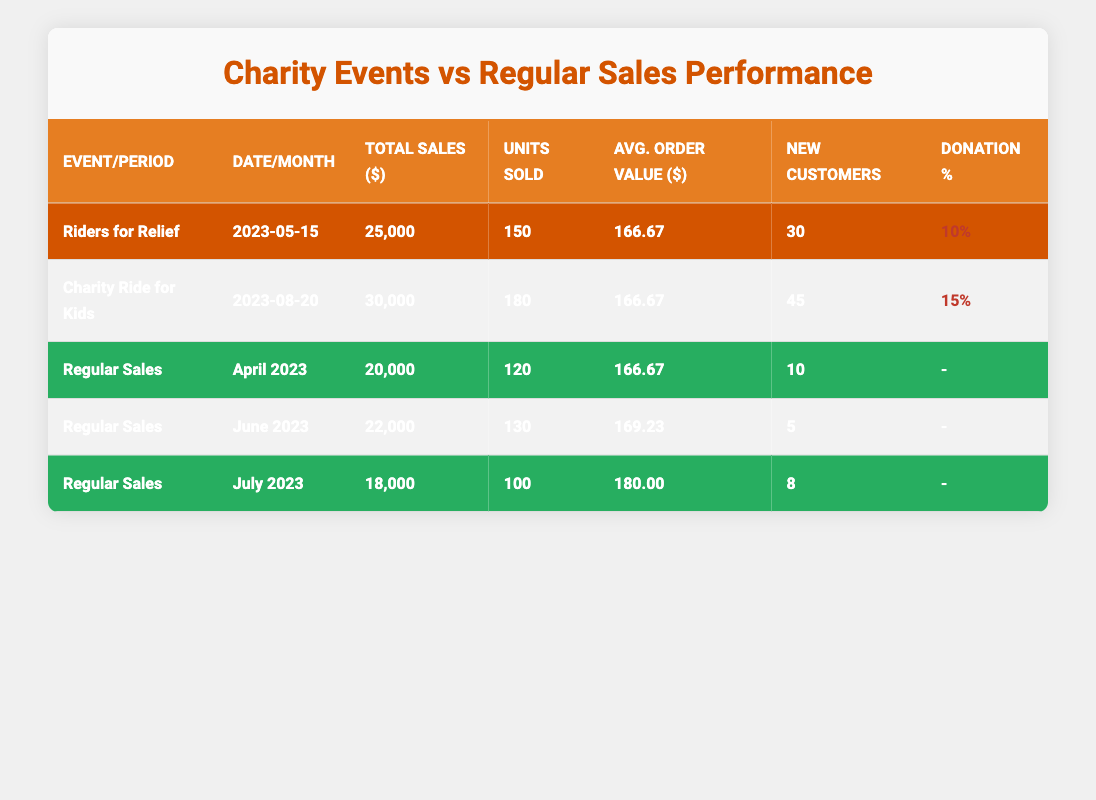What was the total sales amount from the "Charity Ride for Kids" event? The sales performance table shows that the total sales amount from the "Charity Ride for Kids" event is listed in the corresponding row, which is 30000.
Answer: 30000 How many new customers were acquired during the "Riders for Relief" event? Referring to the row for the "Riders for Relief" event in the table, it states that 30 new customers were acquired.
Answer: 30 What is the average order value during the regular sales period for June 2023? Looking at the row for June 2023 under regular sales, the average order value is shown as 169.23.
Answer: 169.23 Which event had the highest total sales and what was the amount? By comparing total sales for each charity event, it's clear that the "Charity Ride for Kids" event had the highest total sales at 30000.
Answer: Charity Ride for Kids, 30000 Did any of the charity events have a donation percentage greater than 10%? In the table, the "Charity Ride for Kids" event has a donation percentage of 15%, which is greater than 10%, while "Riders for Relief” has 10%. Therefore, yes, there is at least one event with a higher percentage.
Answer: Yes What was the total sales amount from regular sales for April, June, and July 2023 combined? The total sales amounts for each of these months are: April 20000, June 22000, and July 18000. Adding them together gives 20000 + 22000 + 18000 = 60000.
Answer: 60000 How many more units were sold during the "Charity Ride for Kids" compared to the April 2023 regular sales period? The units sold during "Charity Ride for Kids" is 180, while in April 2023, it was 120. Calculating the difference: 180 - 120 = 60 units, meaning 60 more were sold during the charity event.
Answer: 60 Which month had the lowest total sales during the regular sales periods? By comparing the total sales for April, June, and July, it's evident that July 2023 had the lowest total sales of 18000.
Answer: July 2023 What was the average donation percentage across both charity events? To find the average donation percentage, add the percentages for both events: 10% + 15% = 25%, and divide by 2 (for 2 events): 25% / 2 = 12.5%.
Answer: 12.5% 